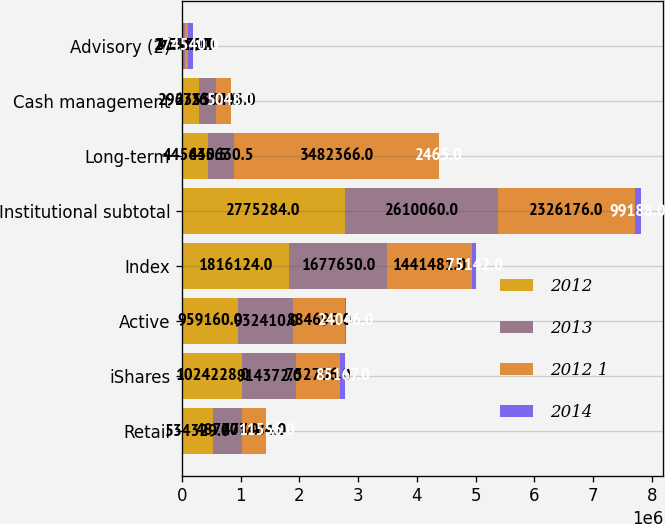<chart> <loc_0><loc_0><loc_500><loc_500><stacked_bar_chart><ecel><fcel>Retail<fcel>iShares<fcel>Active<fcel>Index<fcel>Institutional subtotal<fcel>Long-term<fcel>Cash management<fcel>Advisory (2)<nl><fcel>2012<fcel>534329<fcel>1.02423e+06<fcel>959160<fcel>1.81612e+06<fcel>2.77528e+06<fcel>445630<fcel>296353<fcel>21701<nl><fcel>2013<fcel>487777<fcel>914372<fcel>932410<fcel>1.67765e+06<fcel>2.61006e+06<fcel>445630<fcel>275554<fcel>36325<nl><fcel>2012 1<fcel>403484<fcel>752706<fcel>884695<fcel>1.44148e+06<fcel>2.32618e+06<fcel>3.48237e+06<fcel>263743<fcel>45479<nl><fcel>2014<fcel>11556<fcel>85167<fcel>24046<fcel>75142<fcel>99188<fcel>2465<fcel>5048<fcel>74540<nl></chart> 